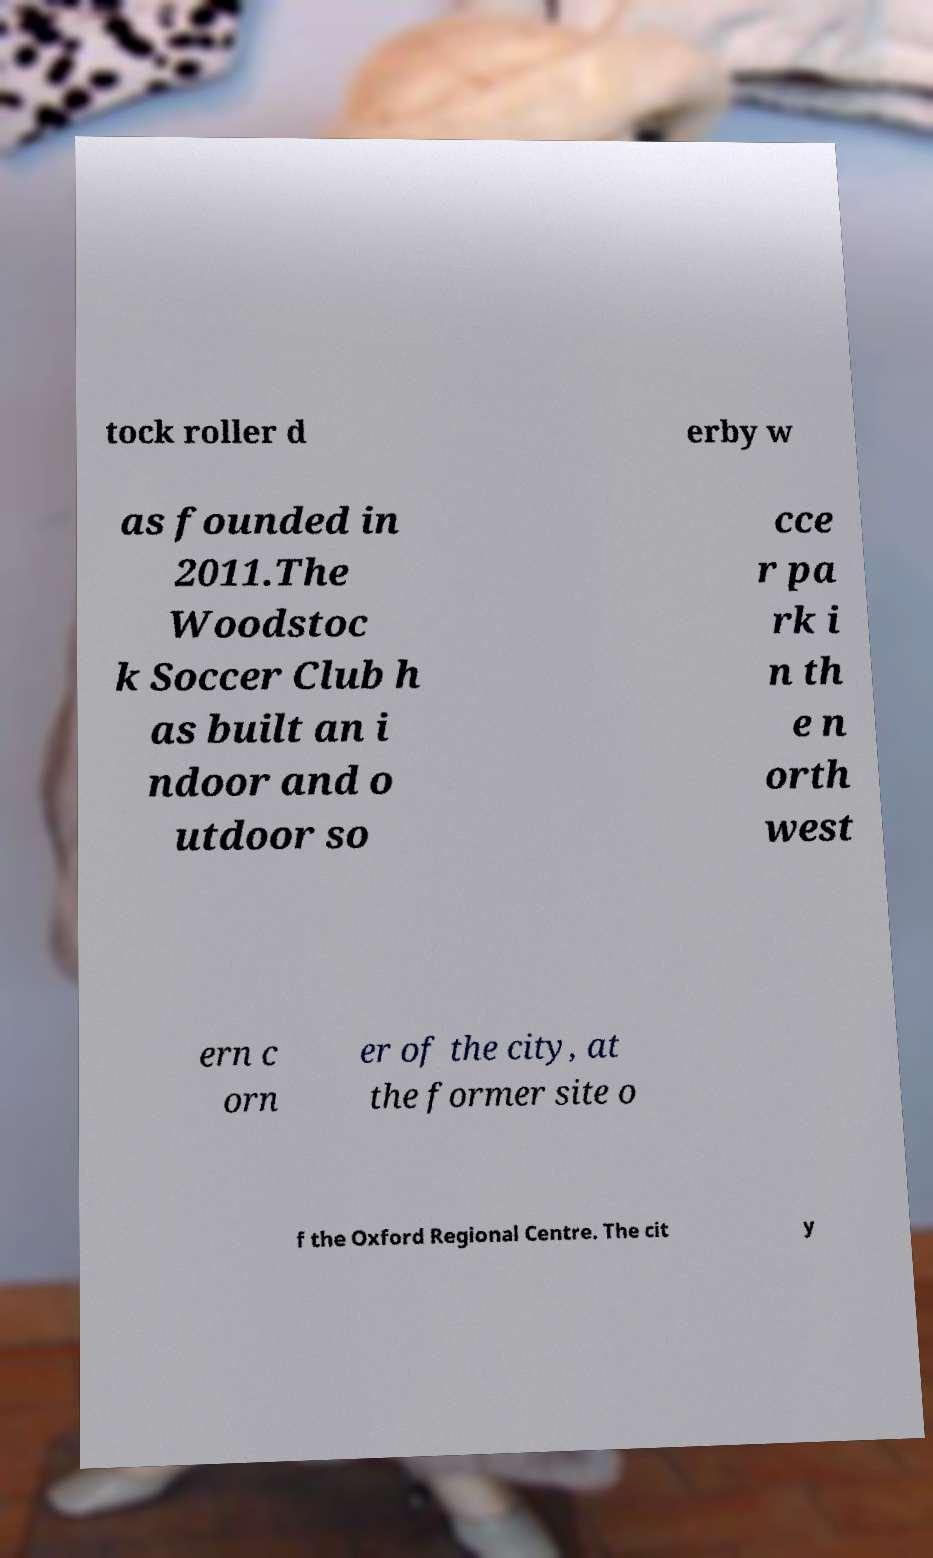Please read and relay the text visible in this image. What does it say? tock roller d erby w as founded in 2011.The Woodstoc k Soccer Club h as built an i ndoor and o utdoor so cce r pa rk i n th e n orth west ern c orn er of the city, at the former site o f the Oxford Regional Centre. The cit y 